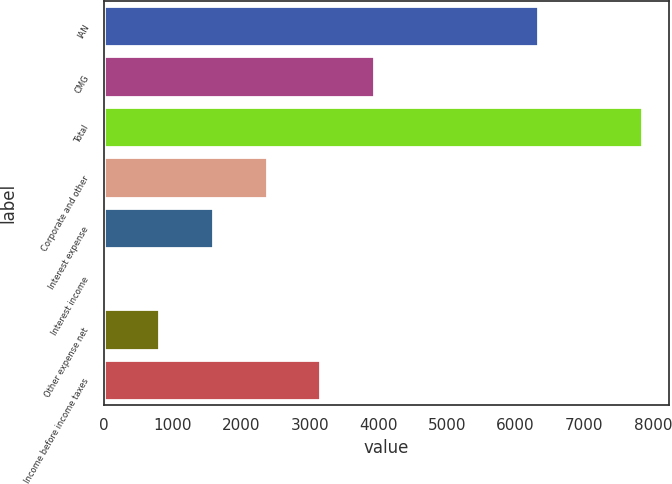<chart> <loc_0><loc_0><loc_500><loc_500><bar_chart><fcel>IAN<fcel>CMG<fcel>Total<fcel>Corporate and other<fcel>Interest expense<fcel>Interest income<fcel>Other expense net<fcel>Income before income taxes<nl><fcel>6319.4<fcel>3933.35<fcel>7846.6<fcel>2368.05<fcel>1585.4<fcel>20.1<fcel>802.75<fcel>3150.7<nl></chart> 